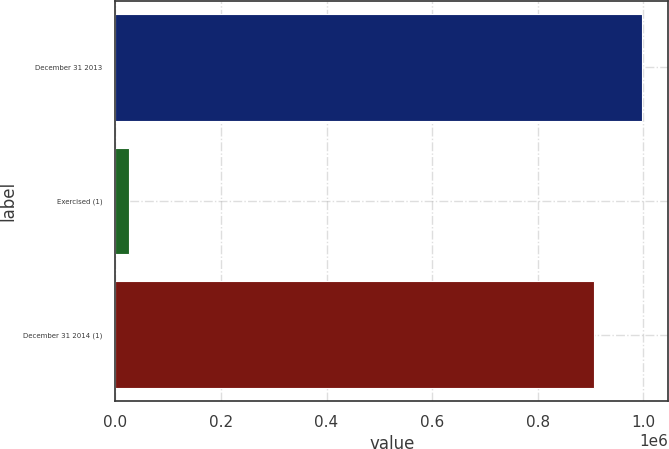<chart> <loc_0><loc_0><loc_500><loc_500><bar_chart><fcel>December 31 2013<fcel>Exercised (1)<fcel>December 31 2014 (1)<nl><fcel>997391<fcel>25039<fcel>906719<nl></chart> 